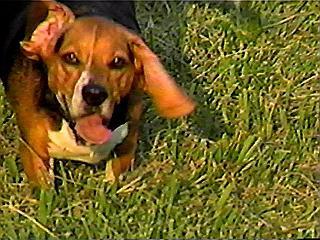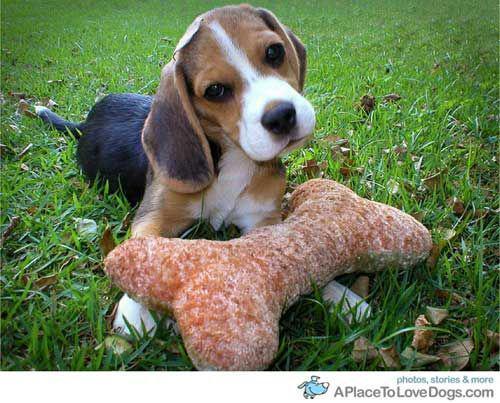The first image is the image on the left, the second image is the image on the right. Assess this claim about the two images: "The left image shows one beagle with its tongue visible". Correct or not? Answer yes or no. Yes. The first image is the image on the left, the second image is the image on the right. Assess this claim about the two images: "There is a single dog lying in the grass in the image on the right.". Correct or not? Answer yes or no. Yes. 